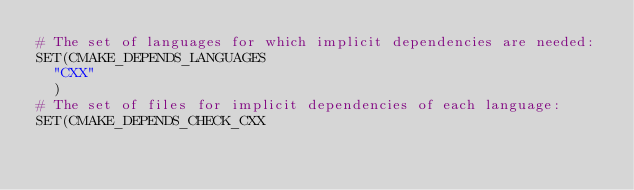<code> <loc_0><loc_0><loc_500><loc_500><_CMake_># The set of languages for which implicit dependencies are needed:
SET(CMAKE_DEPENDS_LANGUAGES
  "CXX"
  )
# The set of files for implicit dependencies of each language:
SET(CMAKE_DEPENDS_CHECK_CXX</code> 